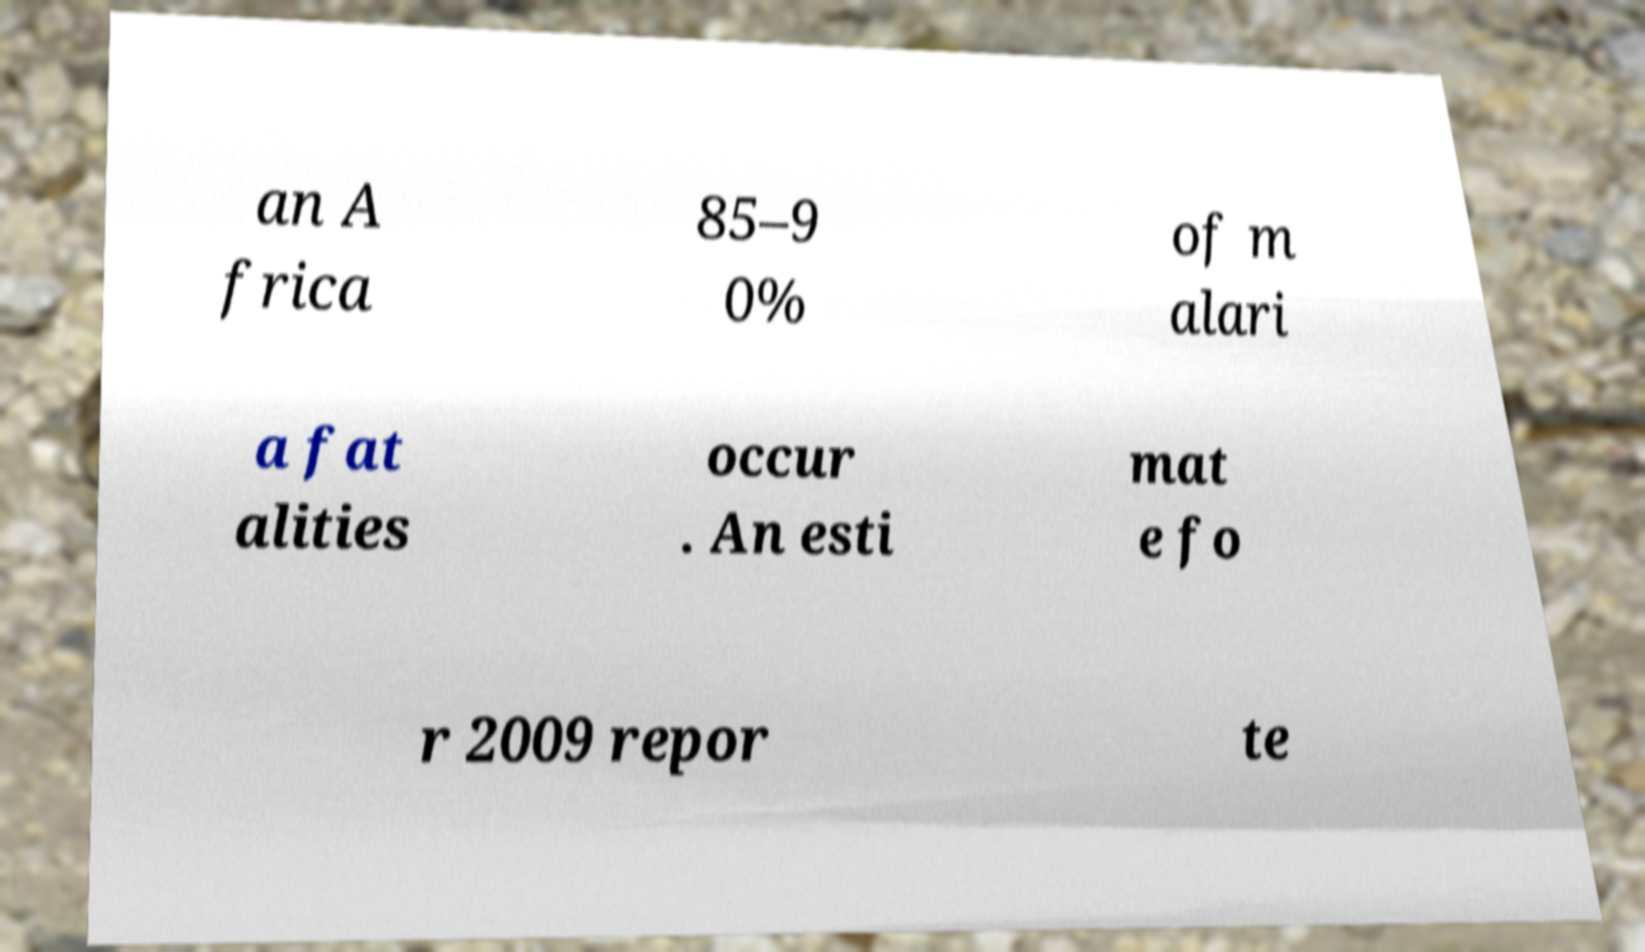I need the written content from this picture converted into text. Can you do that? an A frica 85–9 0% of m alari a fat alities occur . An esti mat e fo r 2009 repor te 